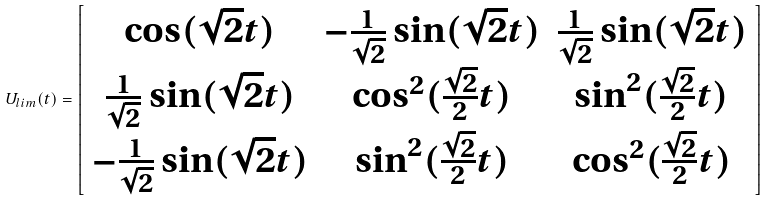Convert formula to latex. <formula><loc_0><loc_0><loc_500><loc_500>U _ { l i m } ( t ) = \left [ \begin{array} { c c c } \cos ( \sqrt { 2 } t ) & - \frac { 1 } { \sqrt { 2 } } \sin ( \sqrt { 2 } t ) & \frac { 1 } { \sqrt { 2 } } \sin ( \sqrt { 2 } t ) \\ \frac { 1 } { \sqrt { 2 } } \sin ( \sqrt { 2 } t ) & \cos ^ { 2 } ( \frac { \sqrt { 2 } } { 2 } t ) & \sin ^ { 2 } ( \frac { \sqrt { 2 } } { 2 } t ) \\ - \frac { 1 } { \sqrt { 2 } } \sin ( \sqrt { 2 } t ) & \sin ^ { 2 } ( \frac { \sqrt { 2 } } { 2 } t ) & \cos ^ { 2 } ( \frac { \sqrt { 2 } } { 2 } t ) \end{array} \right ]</formula> 